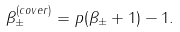Convert formula to latex. <formula><loc_0><loc_0><loc_500><loc_500>\beta ^ { ( c o v e r ) } _ { \pm } = p ( \beta _ { \pm } + 1 ) - 1 .</formula> 